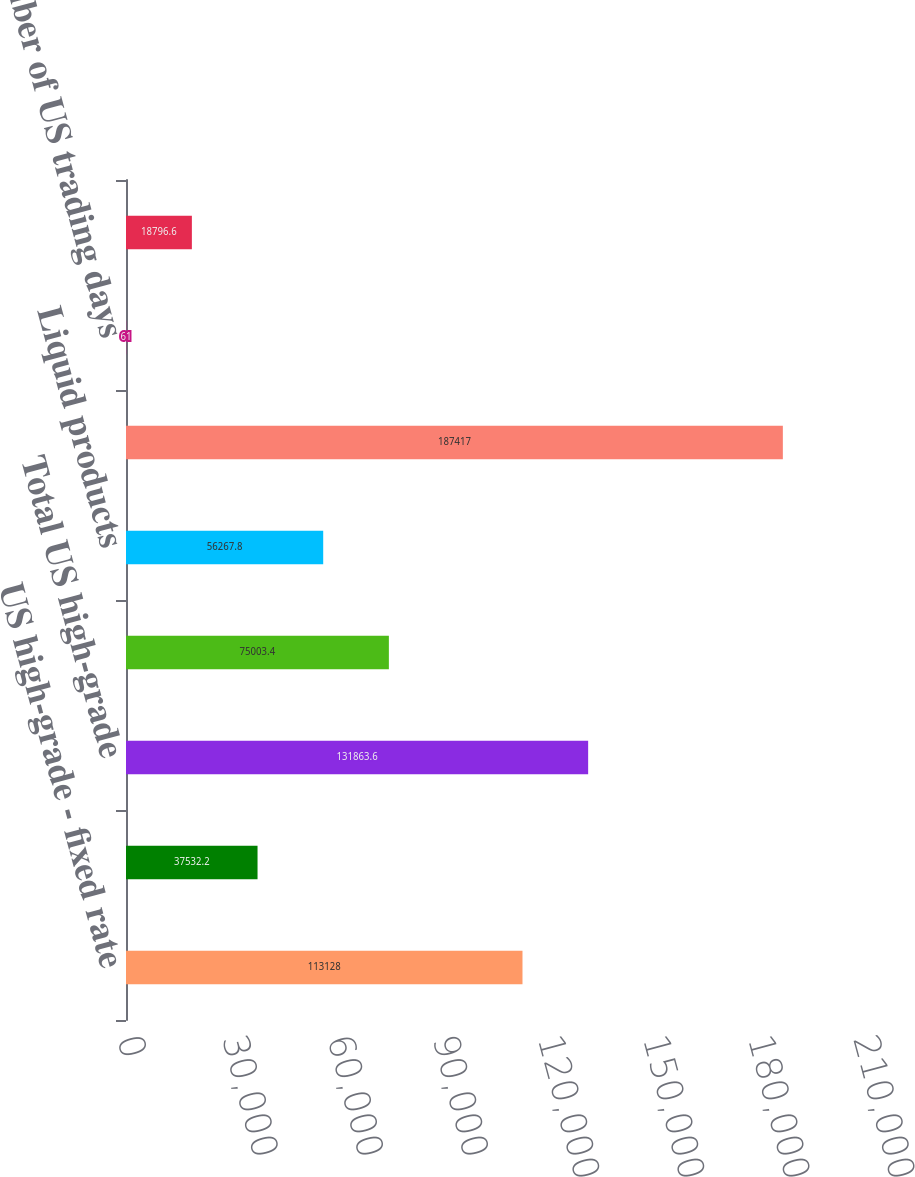Convert chart to OTSL. <chart><loc_0><loc_0><loc_500><loc_500><bar_chart><fcel>US high-grade - fixed rate<fcel>US high-grade - floating rate<fcel>Total US high-grade<fcel>Other credit<fcel>Liquid products<fcel>Total<fcel>Number of US trading days<fcel>Number of UK trading days<nl><fcel>113128<fcel>37532.2<fcel>131864<fcel>75003.4<fcel>56267.8<fcel>187417<fcel>61<fcel>18796.6<nl></chart> 